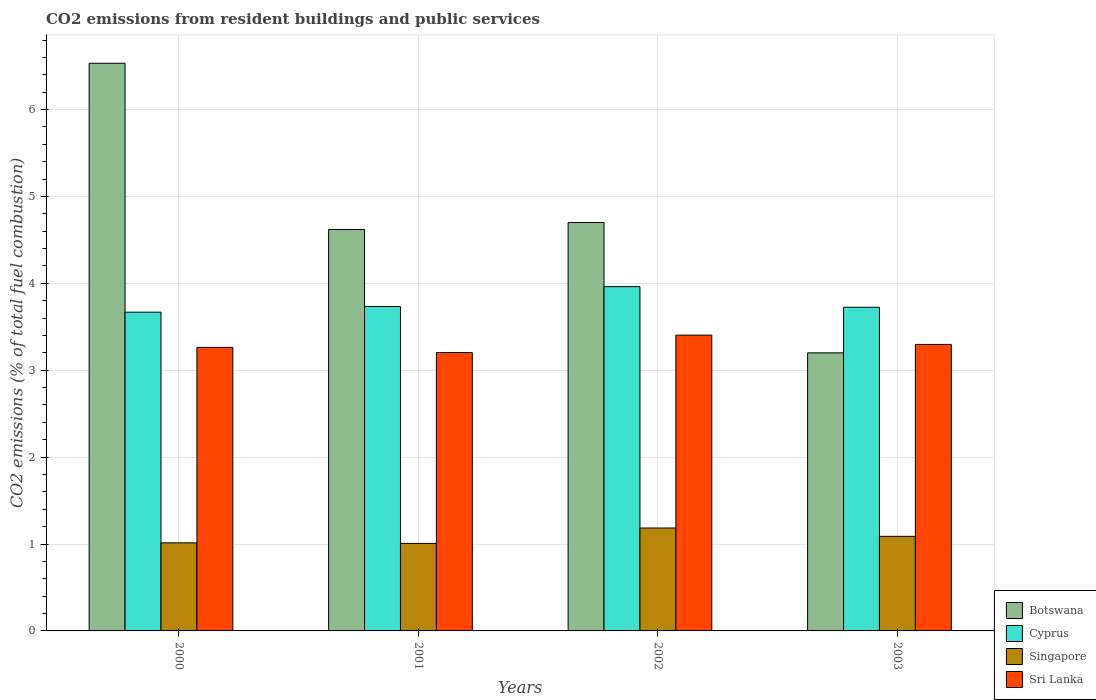Are the number of bars per tick equal to the number of legend labels?
Your answer should be very brief. Yes. How many bars are there on the 2nd tick from the left?
Make the answer very short. 4. How many bars are there on the 4th tick from the right?
Offer a very short reply. 4. What is the total CO2 emitted in Sri Lanka in 2003?
Your answer should be very brief. 3.3. Across all years, what is the maximum total CO2 emitted in Singapore?
Your response must be concise. 1.18. What is the total total CO2 emitted in Botswana in the graph?
Your response must be concise. 19.05. What is the difference between the total CO2 emitted in Botswana in 2001 and that in 2002?
Keep it short and to the point. -0.08. What is the difference between the total CO2 emitted in Botswana in 2000 and the total CO2 emitted in Singapore in 2002?
Provide a short and direct response. 5.35. What is the average total CO2 emitted in Botswana per year?
Your answer should be compact. 4.76. In the year 2002, what is the difference between the total CO2 emitted in Botswana and total CO2 emitted in Singapore?
Give a very brief answer. 3.52. What is the ratio of the total CO2 emitted in Singapore in 2002 to that in 2003?
Provide a short and direct response. 1.09. Is the total CO2 emitted in Singapore in 2000 less than that in 2001?
Ensure brevity in your answer.  No. Is the difference between the total CO2 emitted in Botswana in 2001 and 2002 greater than the difference between the total CO2 emitted in Singapore in 2001 and 2002?
Keep it short and to the point. Yes. What is the difference between the highest and the second highest total CO2 emitted in Sri Lanka?
Offer a very short reply. 0.11. What is the difference between the highest and the lowest total CO2 emitted in Botswana?
Your response must be concise. 3.33. Is it the case that in every year, the sum of the total CO2 emitted in Sri Lanka and total CO2 emitted in Cyprus is greater than the sum of total CO2 emitted in Botswana and total CO2 emitted in Singapore?
Offer a terse response. Yes. What does the 1st bar from the left in 2003 represents?
Your answer should be very brief. Botswana. What does the 2nd bar from the right in 2002 represents?
Your answer should be compact. Singapore. Is it the case that in every year, the sum of the total CO2 emitted in Sri Lanka and total CO2 emitted in Botswana is greater than the total CO2 emitted in Cyprus?
Ensure brevity in your answer.  Yes. How many years are there in the graph?
Give a very brief answer. 4. What is the difference between two consecutive major ticks on the Y-axis?
Ensure brevity in your answer.  1. Does the graph contain any zero values?
Ensure brevity in your answer.  No. Does the graph contain grids?
Make the answer very short. Yes. How many legend labels are there?
Offer a very short reply. 4. What is the title of the graph?
Your answer should be compact. CO2 emissions from resident buildings and public services. Does "Middle income" appear as one of the legend labels in the graph?
Your response must be concise. No. What is the label or title of the X-axis?
Offer a very short reply. Years. What is the label or title of the Y-axis?
Give a very brief answer. CO2 emissions (% of total fuel combustion). What is the CO2 emissions (% of total fuel combustion) in Botswana in 2000?
Make the answer very short. 6.53. What is the CO2 emissions (% of total fuel combustion) of Cyprus in 2000?
Give a very brief answer. 3.67. What is the CO2 emissions (% of total fuel combustion) in Singapore in 2000?
Your answer should be very brief. 1.01. What is the CO2 emissions (% of total fuel combustion) in Sri Lanka in 2000?
Your answer should be very brief. 3.26. What is the CO2 emissions (% of total fuel combustion) in Botswana in 2001?
Your response must be concise. 4.62. What is the CO2 emissions (% of total fuel combustion) in Cyprus in 2001?
Keep it short and to the point. 3.73. What is the CO2 emissions (% of total fuel combustion) in Singapore in 2001?
Provide a succinct answer. 1.01. What is the CO2 emissions (% of total fuel combustion) in Sri Lanka in 2001?
Offer a terse response. 3.2. What is the CO2 emissions (% of total fuel combustion) of Botswana in 2002?
Provide a short and direct response. 4.7. What is the CO2 emissions (% of total fuel combustion) of Cyprus in 2002?
Make the answer very short. 3.96. What is the CO2 emissions (% of total fuel combustion) in Singapore in 2002?
Keep it short and to the point. 1.18. What is the CO2 emissions (% of total fuel combustion) of Sri Lanka in 2002?
Provide a succinct answer. 3.4. What is the CO2 emissions (% of total fuel combustion) of Botswana in 2003?
Provide a short and direct response. 3.2. What is the CO2 emissions (% of total fuel combustion) of Cyprus in 2003?
Make the answer very short. 3.72. What is the CO2 emissions (% of total fuel combustion) of Singapore in 2003?
Your answer should be very brief. 1.09. What is the CO2 emissions (% of total fuel combustion) in Sri Lanka in 2003?
Keep it short and to the point. 3.3. Across all years, what is the maximum CO2 emissions (% of total fuel combustion) in Botswana?
Provide a short and direct response. 6.53. Across all years, what is the maximum CO2 emissions (% of total fuel combustion) in Cyprus?
Provide a succinct answer. 3.96. Across all years, what is the maximum CO2 emissions (% of total fuel combustion) of Singapore?
Provide a succinct answer. 1.18. Across all years, what is the maximum CO2 emissions (% of total fuel combustion) in Sri Lanka?
Keep it short and to the point. 3.4. Across all years, what is the minimum CO2 emissions (% of total fuel combustion) in Botswana?
Your answer should be compact. 3.2. Across all years, what is the minimum CO2 emissions (% of total fuel combustion) of Cyprus?
Your answer should be compact. 3.67. Across all years, what is the minimum CO2 emissions (% of total fuel combustion) of Singapore?
Give a very brief answer. 1.01. Across all years, what is the minimum CO2 emissions (% of total fuel combustion) in Sri Lanka?
Your answer should be very brief. 3.2. What is the total CO2 emissions (% of total fuel combustion) of Botswana in the graph?
Keep it short and to the point. 19.05. What is the total CO2 emissions (% of total fuel combustion) of Cyprus in the graph?
Give a very brief answer. 15.09. What is the total CO2 emissions (% of total fuel combustion) in Singapore in the graph?
Your answer should be compact. 4.29. What is the total CO2 emissions (% of total fuel combustion) in Sri Lanka in the graph?
Ensure brevity in your answer.  13.17. What is the difference between the CO2 emissions (% of total fuel combustion) in Botswana in 2000 and that in 2001?
Provide a succinct answer. 1.91. What is the difference between the CO2 emissions (% of total fuel combustion) of Cyprus in 2000 and that in 2001?
Give a very brief answer. -0.07. What is the difference between the CO2 emissions (% of total fuel combustion) of Singapore in 2000 and that in 2001?
Make the answer very short. 0.01. What is the difference between the CO2 emissions (% of total fuel combustion) in Sri Lanka in 2000 and that in 2001?
Offer a very short reply. 0.06. What is the difference between the CO2 emissions (% of total fuel combustion) of Botswana in 2000 and that in 2002?
Provide a short and direct response. 1.83. What is the difference between the CO2 emissions (% of total fuel combustion) of Cyprus in 2000 and that in 2002?
Ensure brevity in your answer.  -0.29. What is the difference between the CO2 emissions (% of total fuel combustion) of Singapore in 2000 and that in 2002?
Ensure brevity in your answer.  -0.17. What is the difference between the CO2 emissions (% of total fuel combustion) of Sri Lanka in 2000 and that in 2002?
Your response must be concise. -0.14. What is the difference between the CO2 emissions (% of total fuel combustion) in Botswana in 2000 and that in 2003?
Give a very brief answer. 3.33. What is the difference between the CO2 emissions (% of total fuel combustion) in Cyprus in 2000 and that in 2003?
Provide a short and direct response. -0.06. What is the difference between the CO2 emissions (% of total fuel combustion) of Singapore in 2000 and that in 2003?
Offer a very short reply. -0.07. What is the difference between the CO2 emissions (% of total fuel combustion) in Sri Lanka in 2000 and that in 2003?
Provide a succinct answer. -0.03. What is the difference between the CO2 emissions (% of total fuel combustion) in Botswana in 2001 and that in 2002?
Ensure brevity in your answer.  -0.08. What is the difference between the CO2 emissions (% of total fuel combustion) of Cyprus in 2001 and that in 2002?
Your answer should be compact. -0.23. What is the difference between the CO2 emissions (% of total fuel combustion) in Singapore in 2001 and that in 2002?
Provide a succinct answer. -0.18. What is the difference between the CO2 emissions (% of total fuel combustion) of Sri Lanka in 2001 and that in 2002?
Keep it short and to the point. -0.2. What is the difference between the CO2 emissions (% of total fuel combustion) of Botswana in 2001 and that in 2003?
Offer a very short reply. 1.42. What is the difference between the CO2 emissions (% of total fuel combustion) of Cyprus in 2001 and that in 2003?
Offer a terse response. 0.01. What is the difference between the CO2 emissions (% of total fuel combustion) in Singapore in 2001 and that in 2003?
Your response must be concise. -0.08. What is the difference between the CO2 emissions (% of total fuel combustion) in Sri Lanka in 2001 and that in 2003?
Provide a short and direct response. -0.09. What is the difference between the CO2 emissions (% of total fuel combustion) in Botswana in 2002 and that in 2003?
Make the answer very short. 1.5. What is the difference between the CO2 emissions (% of total fuel combustion) of Cyprus in 2002 and that in 2003?
Offer a very short reply. 0.24. What is the difference between the CO2 emissions (% of total fuel combustion) of Singapore in 2002 and that in 2003?
Your answer should be very brief. 0.1. What is the difference between the CO2 emissions (% of total fuel combustion) in Sri Lanka in 2002 and that in 2003?
Provide a short and direct response. 0.11. What is the difference between the CO2 emissions (% of total fuel combustion) of Botswana in 2000 and the CO2 emissions (% of total fuel combustion) of Cyprus in 2001?
Your answer should be compact. 2.8. What is the difference between the CO2 emissions (% of total fuel combustion) of Botswana in 2000 and the CO2 emissions (% of total fuel combustion) of Singapore in 2001?
Your answer should be compact. 5.53. What is the difference between the CO2 emissions (% of total fuel combustion) of Botswana in 2000 and the CO2 emissions (% of total fuel combustion) of Sri Lanka in 2001?
Give a very brief answer. 3.33. What is the difference between the CO2 emissions (% of total fuel combustion) of Cyprus in 2000 and the CO2 emissions (% of total fuel combustion) of Singapore in 2001?
Your answer should be compact. 2.66. What is the difference between the CO2 emissions (% of total fuel combustion) in Cyprus in 2000 and the CO2 emissions (% of total fuel combustion) in Sri Lanka in 2001?
Your response must be concise. 0.46. What is the difference between the CO2 emissions (% of total fuel combustion) of Singapore in 2000 and the CO2 emissions (% of total fuel combustion) of Sri Lanka in 2001?
Give a very brief answer. -2.19. What is the difference between the CO2 emissions (% of total fuel combustion) in Botswana in 2000 and the CO2 emissions (% of total fuel combustion) in Cyprus in 2002?
Make the answer very short. 2.57. What is the difference between the CO2 emissions (% of total fuel combustion) of Botswana in 2000 and the CO2 emissions (% of total fuel combustion) of Singapore in 2002?
Make the answer very short. 5.35. What is the difference between the CO2 emissions (% of total fuel combustion) of Botswana in 2000 and the CO2 emissions (% of total fuel combustion) of Sri Lanka in 2002?
Offer a very short reply. 3.13. What is the difference between the CO2 emissions (% of total fuel combustion) of Cyprus in 2000 and the CO2 emissions (% of total fuel combustion) of Singapore in 2002?
Give a very brief answer. 2.48. What is the difference between the CO2 emissions (% of total fuel combustion) in Cyprus in 2000 and the CO2 emissions (% of total fuel combustion) in Sri Lanka in 2002?
Your answer should be very brief. 0.26. What is the difference between the CO2 emissions (% of total fuel combustion) of Singapore in 2000 and the CO2 emissions (% of total fuel combustion) of Sri Lanka in 2002?
Make the answer very short. -2.39. What is the difference between the CO2 emissions (% of total fuel combustion) in Botswana in 2000 and the CO2 emissions (% of total fuel combustion) in Cyprus in 2003?
Give a very brief answer. 2.81. What is the difference between the CO2 emissions (% of total fuel combustion) of Botswana in 2000 and the CO2 emissions (% of total fuel combustion) of Singapore in 2003?
Provide a short and direct response. 5.44. What is the difference between the CO2 emissions (% of total fuel combustion) of Botswana in 2000 and the CO2 emissions (% of total fuel combustion) of Sri Lanka in 2003?
Keep it short and to the point. 3.24. What is the difference between the CO2 emissions (% of total fuel combustion) of Cyprus in 2000 and the CO2 emissions (% of total fuel combustion) of Singapore in 2003?
Your answer should be very brief. 2.58. What is the difference between the CO2 emissions (% of total fuel combustion) of Cyprus in 2000 and the CO2 emissions (% of total fuel combustion) of Sri Lanka in 2003?
Keep it short and to the point. 0.37. What is the difference between the CO2 emissions (% of total fuel combustion) in Singapore in 2000 and the CO2 emissions (% of total fuel combustion) in Sri Lanka in 2003?
Your answer should be compact. -2.28. What is the difference between the CO2 emissions (% of total fuel combustion) of Botswana in 2001 and the CO2 emissions (% of total fuel combustion) of Cyprus in 2002?
Give a very brief answer. 0.66. What is the difference between the CO2 emissions (% of total fuel combustion) in Botswana in 2001 and the CO2 emissions (% of total fuel combustion) in Singapore in 2002?
Give a very brief answer. 3.44. What is the difference between the CO2 emissions (% of total fuel combustion) of Botswana in 2001 and the CO2 emissions (% of total fuel combustion) of Sri Lanka in 2002?
Your answer should be very brief. 1.22. What is the difference between the CO2 emissions (% of total fuel combustion) of Cyprus in 2001 and the CO2 emissions (% of total fuel combustion) of Singapore in 2002?
Make the answer very short. 2.55. What is the difference between the CO2 emissions (% of total fuel combustion) in Cyprus in 2001 and the CO2 emissions (% of total fuel combustion) in Sri Lanka in 2002?
Your answer should be compact. 0.33. What is the difference between the CO2 emissions (% of total fuel combustion) in Singapore in 2001 and the CO2 emissions (% of total fuel combustion) in Sri Lanka in 2002?
Provide a short and direct response. -2.4. What is the difference between the CO2 emissions (% of total fuel combustion) of Botswana in 2001 and the CO2 emissions (% of total fuel combustion) of Cyprus in 2003?
Make the answer very short. 0.89. What is the difference between the CO2 emissions (% of total fuel combustion) of Botswana in 2001 and the CO2 emissions (% of total fuel combustion) of Singapore in 2003?
Make the answer very short. 3.53. What is the difference between the CO2 emissions (% of total fuel combustion) in Botswana in 2001 and the CO2 emissions (% of total fuel combustion) in Sri Lanka in 2003?
Provide a succinct answer. 1.32. What is the difference between the CO2 emissions (% of total fuel combustion) of Cyprus in 2001 and the CO2 emissions (% of total fuel combustion) of Singapore in 2003?
Keep it short and to the point. 2.65. What is the difference between the CO2 emissions (% of total fuel combustion) in Cyprus in 2001 and the CO2 emissions (% of total fuel combustion) in Sri Lanka in 2003?
Offer a terse response. 0.44. What is the difference between the CO2 emissions (% of total fuel combustion) in Singapore in 2001 and the CO2 emissions (% of total fuel combustion) in Sri Lanka in 2003?
Give a very brief answer. -2.29. What is the difference between the CO2 emissions (% of total fuel combustion) of Botswana in 2002 and the CO2 emissions (% of total fuel combustion) of Cyprus in 2003?
Ensure brevity in your answer.  0.97. What is the difference between the CO2 emissions (% of total fuel combustion) of Botswana in 2002 and the CO2 emissions (% of total fuel combustion) of Singapore in 2003?
Your answer should be very brief. 3.61. What is the difference between the CO2 emissions (% of total fuel combustion) in Botswana in 2002 and the CO2 emissions (% of total fuel combustion) in Sri Lanka in 2003?
Your response must be concise. 1.4. What is the difference between the CO2 emissions (% of total fuel combustion) of Cyprus in 2002 and the CO2 emissions (% of total fuel combustion) of Singapore in 2003?
Provide a succinct answer. 2.87. What is the difference between the CO2 emissions (% of total fuel combustion) in Cyprus in 2002 and the CO2 emissions (% of total fuel combustion) in Sri Lanka in 2003?
Offer a very short reply. 0.67. What is the difference between the CO2 emissions (% of total fuel combustion) in Singapore in 2002 and the CO2 emissions (% of total fuel combustion) in Sri Lanka in 2003?
Provide a succinct answer. -2.11. What is the average CO2 emissions (% of total fuel combustion) in Botswana per year?
Provide a short and direct response. 4.76. What is the average CO2 emissions (% of total fuel combustion) in Cyprus per year?
Make the answer very short. 3.77. What is the average CO2 emissions (% of total fuel combustion) of Singapore per year?
Make the answer very short. 1.07. What is the average CO2 emissions (% of total fuel combustion) in Sri Lanka per year?
Your answer should be compact. 3.29. In the year 2000, what is the difference between the CO2 emissions (% of total fuel combustion) in Botswana and CO2 emissions (% of total fuel combustion) in Cyprus?
Offer a very short reply. 2.86. In the year 2000, what is the difference between the CO2 emissions (% of total fuel combustion) of Botswana and CO2 emissions (% of total fuel combustion) of Singapore?
Your answer should be very brief. 5.52. In the year 2000, what is the difference between the CO2 emissions (% of total fuel combustion) in Botswana and CO2 emissions (% of total fuel combustion) in Sri Lanka?
Your answer should be very brief. 3.27. In the year 2000, what is the difference between the CO2 emissions (% of total fuel combustion) of Cyprus and CO2 emissions (% of total fuel combustion) of Singapore?
Keep it short and to the point. 2.65. In the year 2000, what is the difference between the CO2 emissions (% of total fuel combustion) in Cyprus and CO2 emissions (% of total fuel combustion) in Sri Lanka?
Offer a very short reply. 0.41. In the year 2000, what is the difference between the CO2 emissions (% of total fuel combustion) of Singapore and CO2 emissions (% of total fuel combustion) of Sri Lanka?
Keep it short and to the point. -2.25. In the year 2001, what is the difference between the CO2 emissions (% of total fuel combustion) in Botswana and CO2 emissions (% of total fuel combustion) in Cyprus?
Provide a succinct answer. 0.89. In the year 2001, what is the difference between the CO2 emissions (% of total fuel combustion) in Botswana and CO2 emissions (% of total fuel combustion) in Singapore?
Your answer should be compact. 3.61. In the year 2001, what is the difference between the CO2 emissions (% of total fuel combustion) of Botswana and CO2 emissions (% of total fuel combustion) of Sri Lanka?
Offer a very short reply. 1.42. In the year 2001, what is the difference between the CO2 emissions (% of total fuel combustion) of Cyprus and CO2 emissions (% of total fuel combustion) of Singapore?
Your answer should be very brief. 2.73. In the year 2001, what is the difference between the CO2 emissions (% of total fuel combustion) in Cyprus and CO2 emissions (% of total fuel combustion) in Sri Lanka?
Your answer should be very brief. 0.53. In the year 2001, what is the difference between the CO2 emissions (% of total fuel combustion) of Singapore and CO2 emissions (% of total fuel combustion) of Sri Lanka?
Provide a short and direct response. -2.2. In the year 2002, what is the difference between the CO2 emissions (% of total fuel combustion) in Botswana and CO2 emissions (% of total fuel combustion) in Cyprus?
Make the answer very short. 0.74. In the year 2002, what is the difference between the CO2 emissions (% of total fuel combustion) of Botswana and CO2 emissions (% of total fuel combustion) of Singapore?
Ensure brevity in your answer.  3.52. In the year 2002, what is the difference between the CO2 emissions (% of total fuel combustion) in Botswana and CO2 emissions (% of total fuel combustion) in Sri Lanka?
Offer a terse response. 1.3. In the year 2002, what is the difference between the CO2 emissions (% of total fuel combustion) in Cyprus and CO2 emissions (% of total fuel combustion) in Singapore?
Offer a very short reply. 2.78. In the year 2002, what is the difference between the CO2 emissions (% of total fuel combustion) of Cyprus and CO2 emissions (% of total fuel combustion) of Sri Lanka?
Offer a very short reply. 0.56. In the year 2002, what is the difference between the CO2 emissions (% of total fuel combustion) in Singapore and CO2 emissions (% of total fuel combustion) in Sri Lanka?
Offer a terse response. -2.22. In the year 2003, what is the difference between the CO2 emissions (% of total fuel combustion) in Botswana and CO2 emissions (% of total fuel combustion) in Cyprus?
Offer a terse response. -0.52. In the year 2003, what is the difference between the CO2 emissions (% of total fuel combustion) in Botswana and CO2 emissions (% of total fuel combustion) in Singapore?
Keep it short and to the point. 2.11. In the year 2003, what is the difference between the CO2 emissions (% of total fuel combustion) in Botswana and CO2 emissions (% of total fuel combustion) in Sri Lanka?
Ensure brevity in your answer.  -0.1. In the year 2003, what is the difference between the CO2 emissions (% of total fuel combustion) in Cyprus and CO2 emissions (% of total fuel combustion) in Singapore?
Keep it short and to the point. 2.64. In the year 2003, what is the difference between the CO2 emissions (% of total fuel combustion) in Cyprus and CO2 emissions (% of total fuel combustion) in Sri Lanka?
Ensure brevity in your answer.  0.43. In the year 2003, what is the difference between the CO2 emissions (% of total fuel combustion) of Singapore and CO2 emissions (% of total fuel combustion) of Sri Lanka?
Provide a succinct answer. -2.21. What is the ratio of the CO2 emissions (% of total fuel combustion) of Botswana in 2000 to that in 2001?
Provide a succinct answer. 1.41. What is the ratio of the CO2 emissions (% of total fuel combustion) in Cyprus in 2000 to that in 2001?
Keep it short and to the point. 0.98. What is the ratio of the CO2 emissions (% of total fuel combustion) in Singapore in 2000 to that in 2001?
Provide a succinct answer. 1.01. What is the ratio of the CO2 emissions (% of total fuel combustion) in Sri Lanka in 2000 to that in 2001?
Offer a very short reply. 1.02. What is the ratio of the CO2 emissions (% of total fuel combustion) in Botswana in 2000 to that in 2002?
Keep it short and to the point. 1.39. What is the ratio of the CO2 emissions (% of total fuel combustion) of Cyprus in 2000 to that in 2002?
Provide a succinct answer. 0.93. What is the ratio of the CO2 emissions (% of total fuel combustion) of Singapore in 2000 to that in 2002?
Your answer should be compact. 0.86. What is the ratio of the CO2 emissions (% of total fuel combustion) of Sri Lanka in 2000 to that in 2002?
Offer a very short reply. 0.96. What is the ratio of the CO2 emissions (% of total fuel combustion) in Botswana in 2000 to that in 2003?
Your answer should be compact. 2.04. What is the ratio of the CO2 emissions (% of total fuel combustion) of Cyprus in 2000 to that in 2003?
Provide a short and direct response. 0.98. What is the ratio of the CO2 emissions (% of total fuel combustion) of Singapore in 2000 to that in 2003?
Your answer should be compact. 0.93. What is the ratio of the CO2 emissions (% of total fuel combustion) of Sri Lanka in 2000 to that in 2003?
Give a very brief answer. 0.99. What is the ratio of the CO2 emissions (% of total fuel combustion) of Botswana in 2001 to that in 2002?
Your answer should be very brief. 0.98. What is the ratio of the CO2 emissions (% of total fuel combustion) in Cyprus in 2001 to that in 2002?
Your answer should be compact. 0.94. What is the ratio of the CO2 emissions (% of total fuel combustion) of Singapore in 2001 to that in 2002?
Give a very brief answer. 0.85. What is the ratio of the CO2 emissions (% of total fuel combustion) of Sri Lanka in 2001 to that in 2002?
Offer a very short reply. 0.94. What is the ratio of the CO2 emissions (% of total fuel combustion) of Botswana in 2001 to that in 2003?
Keep it short and to the point. 1.44. What is the ratio of the CO2 emissions (% of total fuel combustion) in Singapore in 2001 to that in 2003?
Give a very brief answer. 0.93. What is the ratio of the CO2 emissions (% of total fuel combustion) of Sri Lanka in 2001 to that in 2003?
Provide a short and direct response. 0.97. What is the ratio of the CO2 emissions (% of total fuel combustion) in Botswana in 2002 to that in 2003?
Make the answer very short. 1.47. What is the ratio of the CO2 emissions (% of total fuel combustion) in Cyprus in 2002 to that in 2003?
Offer a very short reply. 1.06. What is the ratio of the CO2 emissions (% of total fuel combustion) of Singapore in 2002 to that in 2003?
Offer a terse response. 1.09. What is the ratio of the CO2 emissions (% of total fuel combustion) in Sri Lanka in 2002 to that in 2003?
Give a very brief answer. 1.03. What is the difference between the highest and the second highest CO2 emissions (% of total fuel combustion) of Botswana?
Your response must be concise. 1.83. What is the difference between the highest and the second highest CO2 emissions (% of total fuel combustion) of Cyprus?
Your response must be concise. 0.23. What is the difference between the highest and the second highest CO2 emissions (% of total fuel combustion) in Singapore?
Offer a very short reply. 0.1. What is the difference between the highest and the second highest CO2 emissions (% of total fuel combustion) in Sri Lanka?
Ensure brevity in your answer.  0.11. What is the difference between the highest and the lowest CO2 emissions (% of total fuel combustion) of Botswana?
Ensure brevity in your answer.  3.33. What is the difference between the highest and the lowest CO2 emissions (% of total fuel combustion) in Cyprus?
Keep it short and to the point. 0.29. What is the difference between the highest and the lowest CO2 emissions (% of total fuel combustion) in Singapore?
Offer a very short reply. 0.18. 